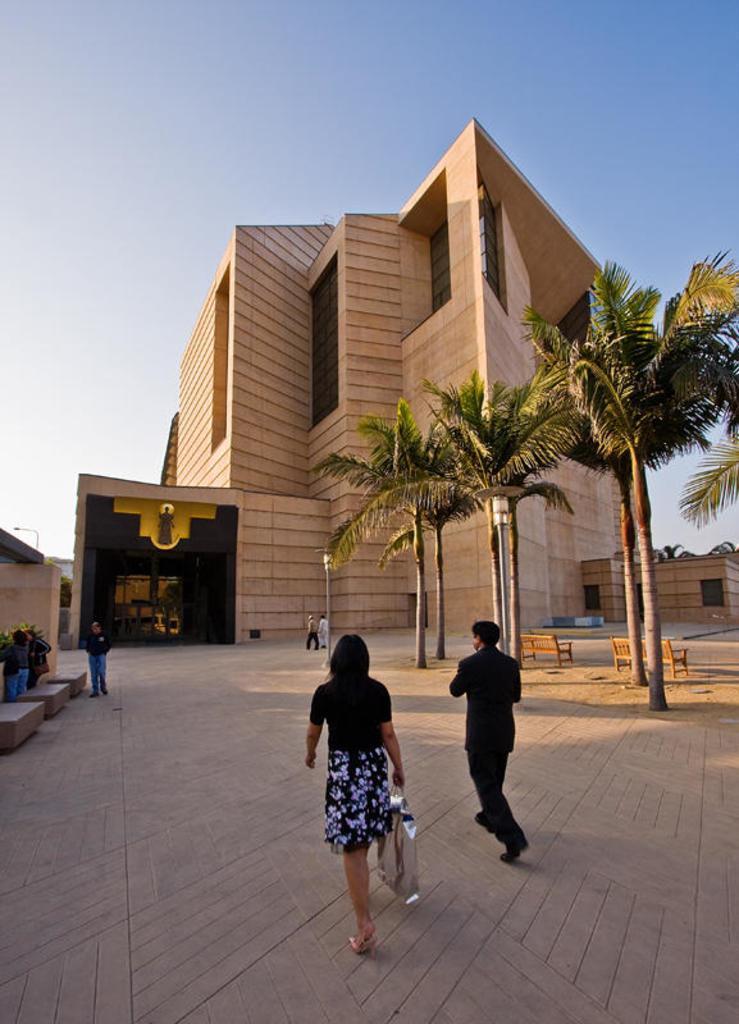Could you give a brief overview of what you see in this image? In this image we can see a woman is holding a bag and walking on the ground and a man is also walking on the ground. In the background we can see few persons, trees, plants, benches on the ground, buildings, windows, poles and sky. 